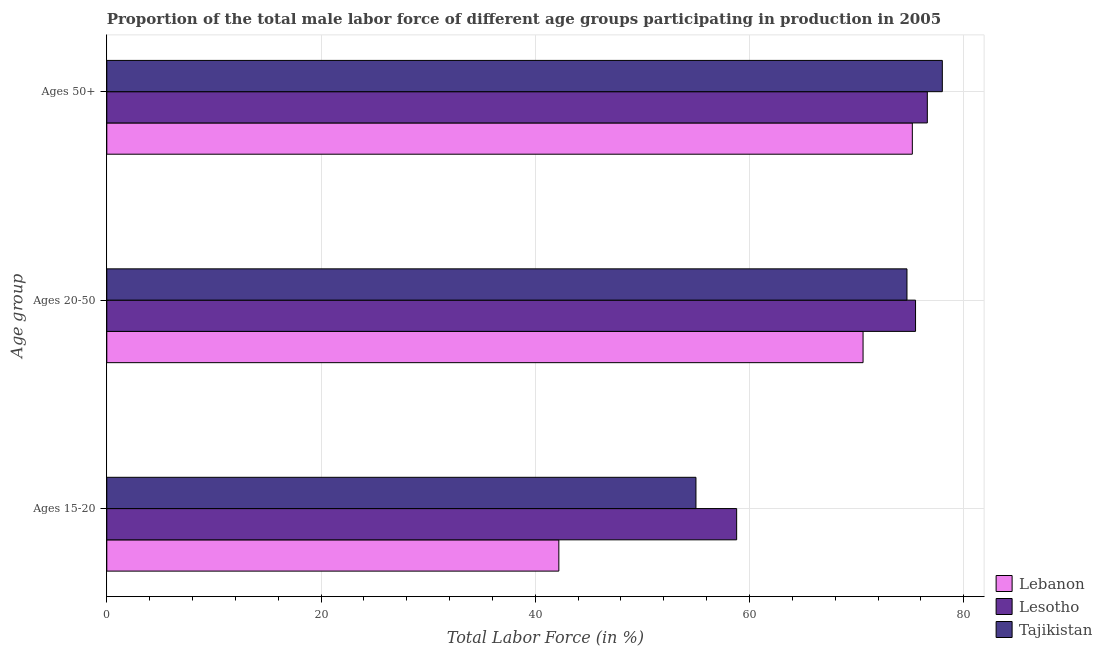How many different coloured bars are there?
Make the answer very short. 3. Are the number of bars on each tick of the Y-axis equal?
Make the answer very short. Yes. How many bars are there on the 2nd tick from the top?
Offer a very short reply. 3. How many bars are there on the 1st tick from the bottom?
Your answer should be very brief. 3. What is the label of the 2nd group of bars from the top?
Make the answer very short. Ages 20-50. What is the percentage of male labor force within the age group 15-20 in Lebanon?
Give a very brief answer. 42.2. Across all countries, what is the maximum percentage of male labor force within the age group 15-20?
Offer a very short reply. 58.8. Across all countries, what is the minimum percentage of male labor force above age 50?
Your response must be concise. 75.2. In which country was the percentage of male labor force above age 50 maximum?
Provide a succinct answer. Tajikistan. In which country was the percentage of male labor force within the age group 15-20 minimum?
Your answer should be very brief. Lebanon. What is the total percentage of male labor force above age 50 in the graph?
Provide a succinct answer. 229.8. What is the difference between the percentage of male labor force within the age group 15-20 in Tajikistan and that in Lebanon?
Offer a very short reply. 12.8. What is the difference between the percentage of male labor force within the age group 20-50 in Lebanon and the percentage of male labor force above age 50 in Tajikistan?
Give a very brief answer. -7.4. What is the average percentage of male labor force within the age group 20-50 per country?
Offer a terse response. 73.6. What is the difference between the percentage of male labor force within the age group 20-50 and percentage of male labor force within the age group 15-20 in Lebanon?
Give a very brief answer. 28.4. What is the ratio of the percentage of male labor force within the age group 20-50 in Tajikistan to that in Lebanon?
Provide a short and direct response. 1.06. Is the difference between the percentage of male labor force within the age group 15-20 in Lebanon and Lesotho greater than the difference between the percentage of male labor force above age 50 in Lebanon and Lesotho?
Give a very brief answer. No. What is the difference between the highest and the second highest percentage of male labor force within the age group 15-20?
Provide a succinct answer. 3.8. What is the difference between the highest and the lowest percentage of male labor force within the age group 20-50?
Provide a succinct answer. 4.9. In how many countries, is the percentage of male labor force within the age group 20-50 greater than the average percentage of male labor force within the age group 20-50 taken over all countries?
Offer a terse response. 2. What does the 3rd bar from the top in Ages 15-20 represents?
Give a very brief answer. Lebanon. What does the 1st bar from the bottom in Ages 50+ represents?
Provide a short and direct response. Lebanon. Are all the bars in the graph horizontal?
Your response must be concise. Yes. Does the graph contain any zero values?
Your answer should be very brief. No. How many legend labels are there?
Offer a very short reply. 3. What is the title of the graph?
Provide a succinct answer. Proportion of the total male labor force of different age groups participating in production in 2005. What is the label or title of the Y-axis?
Provide a succinct answer. Age group. What is the Total Labor Force (in %) in Lebanon in Ages 15-20?
Keep it short and to the point. 42.2. What is the Total Labor Force (in %) of Lesotho in Ages 15-20?
Your answer should be very brief. 58.8. What is the Total Labor Force (in %) of Lebanon in Ages 20-50?
Provide a short and direct response. 70.6. What is the Total Labor Force (in %) of Lesotho in Ages 20-50?
Give a very brief answer. 75.5. What is the Total Labor Force (in %) of Tajikistan in Ages 20-50?
Offer a very short reply. 74.7. What is the Total Labor Force (in %) of Lebanon in Ages 50+?
Provide a succinct answer. 75.2. What is the Total Labor Force (in %) of Lesotho in Ages 50+?
Keep it short and to the point. 76.6. What is the Total Labor Force (in %) of Tajikistan in Ages 50+?
Your response must be concise. 78. Across all Age group, what is the maximum Total Labor Force (in %) in Lebanon?
Offer a very short reply. 75.2. Across all Age group, what is the maximum Total Labor Force (in %) of Lesotho?
Your answer should be compact. 76.6. Across all Age group, what is the maximum Total Labor Force (in %) in Tajikistan?
Give a very brief answer. 78. Across all Age group, what is the minimum Total Labor Force (in %) in Lebanon?
Give a very brief answer. 42.2. Across all Age group, what is the minimum Total Labor Force (in %) of Lesotho?
Offer a terse response. 58.8. Across all Age group, what is the minimum Total Labor Force (in %) of Tajikistan?
Offer a very short reply. 55. What is the total Total Labor Force (in %) in Lebanon in the graph?
Your answer should be very brief. 188. What is the total Total Labor Force (in %) of Lesotho in the graph?
Give a very brief answer. 210.9. What is the total Total Labor Force (in %) in Tajikistan in the graph?
Provide a succinct answer. 207.7. What is the difference between the Total Labor Force (in %) in Lebanon in Ages 15-20 and that in Ages 20-50?
Your answer should be compact. -28.4. What is the difference between the Total Labor Force (in %) in Lesotho in Ages 15-20 and that in Ages 20-50?
Your answer should be compact. -16.7. What is the difference between the Total Labor Force (in %) in Tajikistan in Ages 15-20 and that in Ages 20-50?
Your answer should be very brief. -19.7. What is the difference between the Total Labor Force (in %) of Lebanon in Ages 15-20 and that in Ages 50+?
Your answer should be compact. -33. What is the difference between the Total Labor Force (in %) in Lesotho in Ages 15-20 and that in Ages 50+?
Ensure brevity in your answer.  -17.8. What is the difference between the Total Labor Force (in %) of Tajikistan in Ages 15-20 and that in Ages 50+?
Provide a short and direct response. -23. What is the difference between the Total Labor Force (in %) in Lebanon in Ages 20-50 and that in Ages 50+?
Provide a succinct answer. -4.6. What is the difference between the Total Labor Force (in %) of Tajikistan in Ages 20-50 and that in Ages 50+?
Your answer should be compact. -3.3. What is the difference between the Total Labor Force (in %) in Lebanon in Ages 15-20 and the Total Labor Force (in %) in Lesotho in Ages 20-50?
Your answer should be very brief. -33.3. What is the difference between the Total Labor Force (in %) of Lebanon in Ages 15-20 and the Total Labor Force (in %) of Tajikistan in Ages 20-50?
Your answer should be compact. -32.5. What is the difference between the Total Labor Force (in %) in Lesotho in Ages 15-20 and the Total Labor Force (in %) in Tajikistan in Ages 20-50?
Your answer should be very brief. -15.9. What is the difference between the Total Labor Force (in %) in Lebanon in Ages 15-20 and the Total Labor Force (in %) in Lesotho in Ages 50+?
Your answer should be compact. -34.4. What is the difference between the Total Labor Force (in %) in Lebanon in Ages 15-20 and the Total Labor Force (in %) in Tajikistan in Ages 50+?
Give a very brief answer. -35.8. What is the difference between the Total Labor Force (in %) in Lesotho in Ages 15-20 and the Total Labor Force (in %) in Tajikistan in Ages 50+?
Ensure brevity in your answer.  -19.2. What is the difference between the Total Labor Force (in %) in Lesotho in Ages 20-50 and the Total Labor Force (in %) in Tajikistan in Ages 50+?
Offer a terse response. -2.5. What is the average Total Labor Force (in %) of Lebanon per Age group?
Your answer should be compact. 62.67. What is the average Total Labor Force (in %) of Lesotho per Age group?
Your response must be concise. 70.3. What is the average Total Labor Force (in %) in Tajikistan per Age group?
Keep it short and to the point. 69.23. What is the difference between the Total Labor Force (in %) of Lebanon and Total Labor Force (in %) of Lesotho in Ages 15-20?
Offer a very short reply. -16.6. What is the difference between the Total Labor Force (in %) in Lesotho and Total Labor Force (in %) in Tajikistan in Ages 15-20?
Ensure brevity in your answer.  3.8. What is the difference between the Total Labor Force (in %) of Lebanon and Total Labor Force (in %) of Lesotho in Ages 20-50?
Offer a very short reply. -4.9. What is the difference between the Total Labor Force (in %) in Lebanon and Total Labor Force (in %) in Tajikistan in Ages 50+?
Ensure brevity in your answer.  -2.8. What is the difference between the Total Labor Force (in %) of Lesotho and Total Labor Force (in %) of Tajikistan in Ages 50+?
Ensure brevity in your answer.  -1.4. What is the ratio of the Total Labor Force (in %) in Lebanon in Ages 15-20 to that in Ages 20-50?
Make the answer very short. 0.6. What is the ratio of the Total Labor Force (in %) of Lesotho in Ages 15-20 to that in Ages 20-50?
Provide a succinct answer. 0.78. What is the ratio of the Total Labor Force (in %) in Tajikistan in Ages 15-20 to that in Ages 20-50?
Provide a succinct answer. 0.74. What is the ratio of the Total Labor Force (in %) in Lebanon in Ages 15-20 to that in Ages 50+?
Offer a very short reply. 0.56. What is the ratio of the Total Labor Force (in %) of Lesotho in Ages 15-20 to that in Ages 50+?
Make the answer very short. 0.77. What is the ratio of the Total Labor Force (in %) of Tajikistan in Ages 15-20 to that in Ages 50+?
Your answer should be compact. 0.71. What is the ratio of the Total Labor Force (in %) in Lebanon in Ages 20-50 to that in Ages 50+?
Make the answer very short. 0.94. What is the ratio of the Total Labor Force (in %) in Lesotho in Ages 20-50 to that in Ages 50+?
Your answer should be very brief. 0.99. What is the ratio of the Total Labor Force (in %) of Tajikistan in Ages 20-50 to that in Ages 50+?
Give a very brief answer. 0.96. What is the difference between the highest and the second highest Total Labor Force (in %) in Lebanon?
Provide a short and direct response. 4.6. What is the difference between the highest and the lowest Total Labor Force (in %) in Lebanon?
Keep it short and to the point. 33. What is the difference between the highest and the lowest Total Labor Force (in %) of Lesotho?
Offer a very short reply. 17.8. What is the difference between the highest and the lowest Total Labor Force (in %) of Tajikistan?
Provide a short and direct response. 23. 